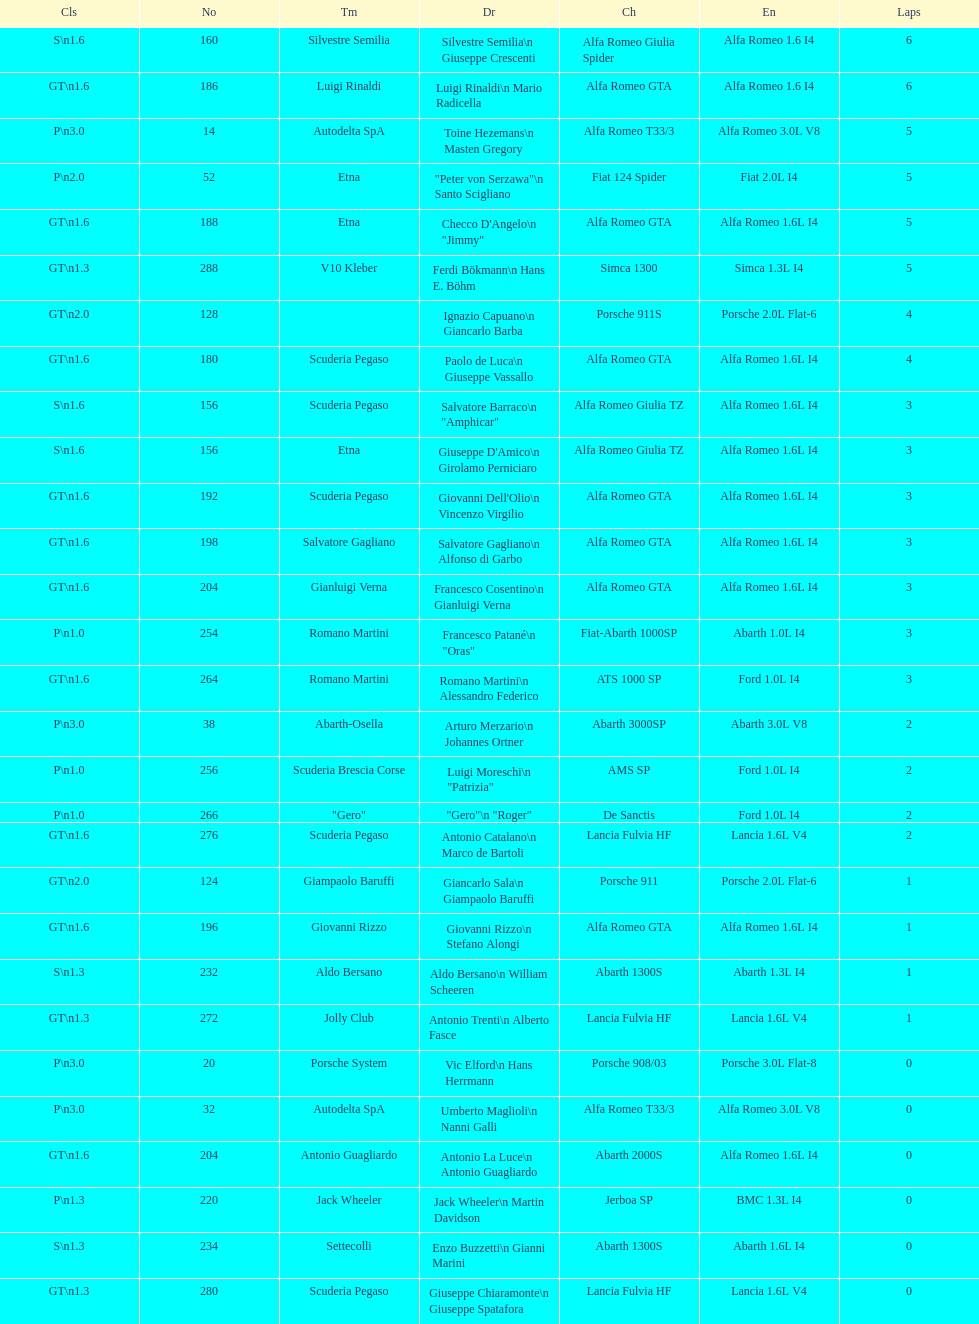His nickname is "jimmy," but what is his full name? Checco D'Angelo. 